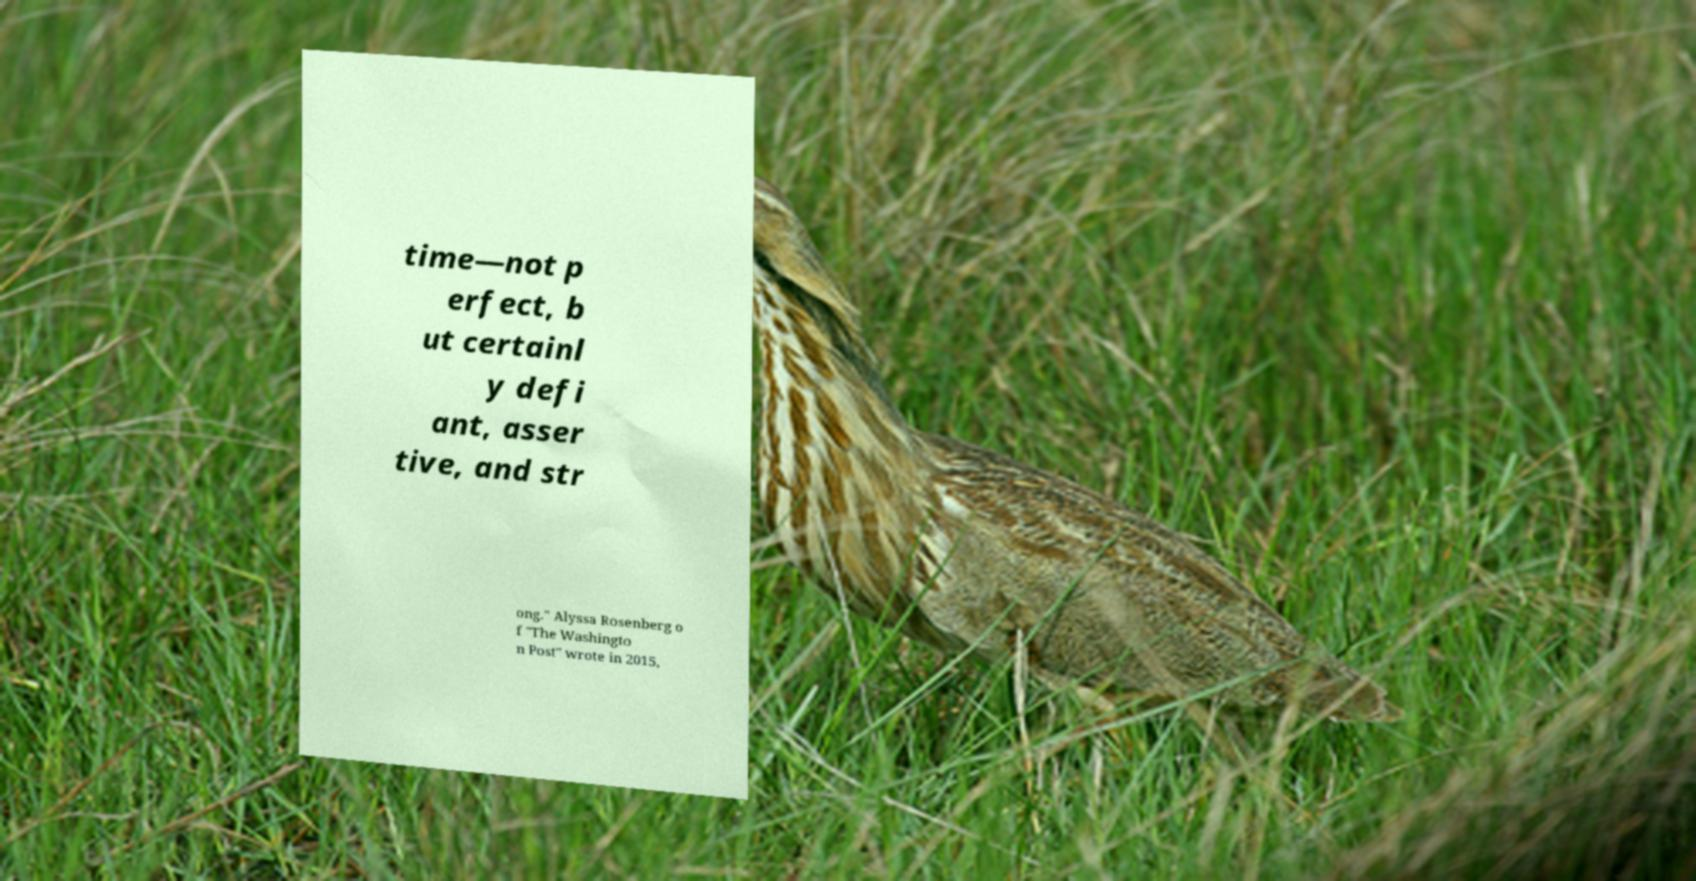Please read and relay the text visible in this image. What does it say? time—not p erfect, b ut certainl y defi ant, asser tive, and str ong." Alyssa Rosenberg o f "The Washingto n Post" wrote in 2015, 